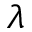Convert formula to latex. <formula><loc_0><loc_0><loc_500><loc_500>\lambda</formula> 